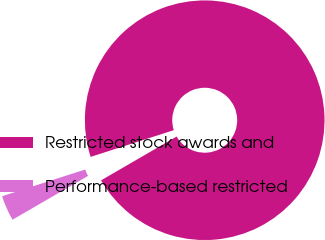<chart> <loc_0><loc_0><loc_500><loc_500><pie_chart><fcel>Restricted stock awards and<fcel>Performance-based restricted<nl><fcel>96.58%<fcel>3.42%<nl></chart> 